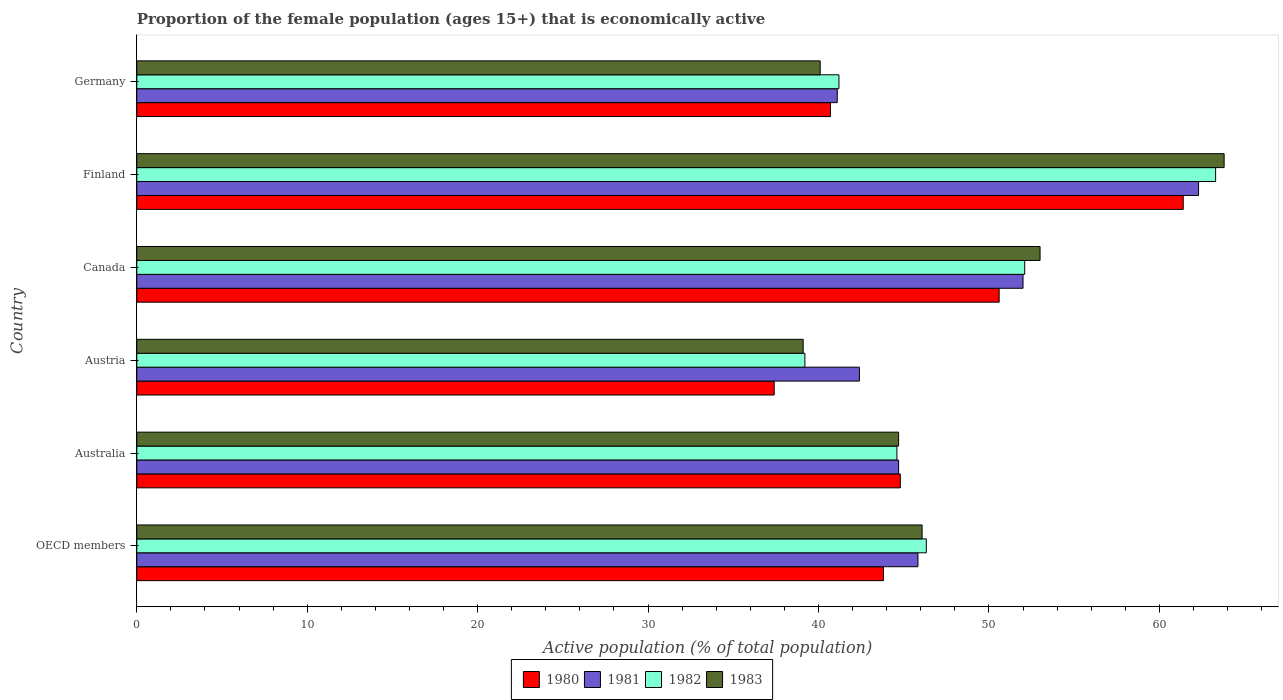How many different coloured bars are there?
Make the answer very short. 4. How many groups of bars are there?
Offer a terse response. 6. Are the number of bars per tick equal to the number of legend labels?
Your answer should be compact. Yes. How many bars are there on the 3rd tick from the top?
Your answer should be compact. 4. How many bars are there on the 1st tick from the bottom?
Your answer should be compact. 4. What is the label of the 4th group of bars from the top?
Make the answer very short. Austria. What is the proportion of the female population that is economically active in 1983 in Germany?
Make the answer very short. 40.1. Across all countries, what is the maximum proportion of the female population that is economically active in 1980?
Provide a succinct answer. 61.4. Across all countries, what is the minimum proportion of the female population that is economically active in 1980?
Make the answer very short. 37.4. In which country was the proportion of the female population that is economically active in 1981 minimum?
Your answer should be very brief. Germany. What is the total proportion of the female population that is economically active in 1983 in the graph?
Offer a terse response. 286.78. What is the difference between the proportion of the female population that is economically active in 1981 in Austria and that in Germany?
Offer a very short reply. 1.3. What is the difference between the proportion of the female population that is economically active in 1981 in OECD members and the proportion of the female population that is economically active in 1982 in Finland?
Provide a short and direct response. -17.46. What is the average proportion of the female population that is economically active in 1983 per country?
Your answer should be very brief. 47.8. What is the difference between the proportion of the female population that is economically active in 1981 and proportion of the female population that is economically active in 1980 in Finland?
Provide a short and direct response. 0.9. What is the ratio of the proportion of the female population that is economically active in 1982 in Austria to that in Finland?
Your response must be concise. 0.62. Is the difference between the proportion of the female population that is economically active in 1981 in Austria and Finland greater than the difference between the proportion of the female population that is economically active in 1980 in Austria and Finland?
Your answer should be very brief. Yes. What is the difference between the highest and the second highest proportion of the female population that is economically active in 1982?
Ensure brevity in your answer.  11.2. What is the difference between the highest and the lowest proportion of the female population that is economically active in 1982?
Provide a short and direct response. 24.1. In how many countries, is the proportion of the female population that is economically active in 1980 greater than the average proportion of the female population that is economically active in 1980 taken over all countries?
Keep it short and to the point. 2. Is it the case that in every country, the sum of the proportion of the female population that is economically active in 1983 and proportion of the female population that is economically active in 1980 is greater than the sum of proportion of the female population that is economically active in 1981 and proportion of the female population that is economically active in 1982?
Offer a very short reply. No. Is it the case that in every country, the sum of the proportion of the female population that is economically active in 1980 and proportion of the female population that is economically active in 1983 is greater than the proportion of the female population that is economically active in 1982?
Your answer should be compact. Yes. Are all the bars in the graph horizontal?
Provide a succinct answer. Yes. Are the values on the major ticks of X-axis written in scientific E-notation?
Your answer should be very brief. No. Does the graph contain any zero values?
Keep it short and to the point. No. How are the legend labels stacked?
Offer a very short reply. Horizontal. What is the title of the graph?
Your answer should be very brief. Proportion of the female population (ages 15+) that is economically active. What is the label or title of the X-axis?
Keep it short and to the point. Active population (% of total population). What is the Active population (% of total population) in 1980 in OECD members?
Offer a terse response. 43.81. What is the Active population (% of total population) of 1981 in OECD members?
Your response must be concise. 45.84. What is the Active population (% of total population) of 1982 in OECD members?
Offer a terse response. 46.32. What is the Active population (% of total population) of 1983 in OECD members?
Your response must be concise. 46.08. What is the Active population (% of total population) of 1980 in Australia?
Give a very brief answer. 44.8. What is the Active population (% of total population) of 1981 in Australia?
Offer a terse response. 44.7. What is the Active population (% of total population) of 1982 in Australia?
Offer a very short reply. 44.6. What is the Active population (% of total population) of 1983 in Australia?
Your answer should be very brief. 44.7. What is the Active population (% of total population) of 1980 in Austria?
Keep it short and to the point. 37.4. What is the Active population (% of total population) of 1981 in Austria?
Offer a very short reply. 42.4. What is the Active population (% of total population) of 1982 in Austria?
Offer a very short reply. 39.2. What is the Active population (% of total population) in 1983 in Austria?
Give a very brief answer. 39.1. What is the Active population (% of total population) in 1980 in Canada?
Provide a short and direct response. 50.6. What is the Active population (% of total population) in 1981 in Canada?
Offer a very short reply. 52. What is the Active population (% of total population) in 1982 in Canada?
Keep it short and to the point. 52.1. What is the Active population (% of total population) in 1983 in Canada?
Keep it short and to the point. 53. What is the Active population (% of total population) in 1980 in Finland?
Offer a very short reply. 61.4. What is the Active population (% of total population) in 1981 in Finland?
Provide a short and direct response. 62.3. What is the Active population (% of total population) of 1982 in Finland?
Offer a very short reply. 63.3. What is the Active population (% of total population) of 1983 in Finland?
Your answer should be compact. 63.8. What is the Active population (% of total population) in 1980 in Germany?
Offer a terse response. 40.7. What is the Active population (% of total population) of 1981 in Germany?
Provide a short and direct response. 41.1. What is the Active population (% of total population) in 1982 in Germany?
Offer a terse response. 41.2. What is the Active population (% of total population) of 1983 in Germany?
Your answer should be very brief. 40.1. Across all countries, what is the maximum Active population (% of total population) in 1980?
Make the answer very short. 61.4. Across all countries, what is the maximum Active population (% of total population) in 1981?
Provide a succinct answer. 62.3. Across all countries, what is the maximum Active population (% of total population) of 1982?
Your answer should be compact. 63.3. Across all countries, what is the maximum Active population (% of total population) of 1983?
Your answer should be very brief. 63.8. Across all countries, what is the minimum Active population (% of total population) of 1980?
Give a very brief answer. 37.4. Across all countries, what is the minimum Active population (% of total population) of 1981?
Your answer should be compact. 41.1. Across all countries, what is the minimum Active population (% of total population) of 1982?
Your answer should be very brief. 39.2. Across all countries, what is the minimum Active population (% of total population) of 1983?
Your answer should be compact. 39.1. What is the total Active population (% of total population) in 1980 in the graph?
Offer a terse response. 278.71. What is the total Active population (% of total population) of 1981 in the graph?
Ensure brevity in your answer.  288.34. What is the total Active population (% of total population) of 1982 in the graph?
Offer a very short reply. 286.72. What is the total Active population (% of total population) in 1983 in the graph?
Your response must be concise. 286.78. What is the difference between the Active population (% of total population) of 1980 in OECD members and that in Australia?
Offer a terse response. -0.99. What is the difference between the Active population (% of total population) in 1981 in OECD members and that in Australia?
Make the answer very short. 1.14. What is the difference between the Active population (% of total population) in 1982 in OECD members and that in Australia?
Give a very brief answer. 1.72. What is the difference between the Active population (% of total population) of 1983 in OECD members and that in Australia?
Offer a terse response. 1.38. What is the difference between the Active population (% of total population) in 1980 in OECD members and that in Austria?
Make the answer very short. 6.41. What is the difference between the Active population (% of total population) in 1981 in OECD members and that in Austria?
Give a very brief answer. 3.44. What is the difference between the Active population (% of total population) in 1982 in OECD members and that in Austria?
Make the answer very short. 7.12. What is the difference between the Active population (% of total population) in 1983 in OECD members and that in Austria?
Offer a very short reply. 6.98. What is the difference between the Active population (% of total population) of 1980 in OECD members and that in Canada?
Your response must be concise. -6.79. What is the difference between the Active population (% of total population) of 1981 in OECD members and that in Canada?
Make the answer very short. -6.16. What is the difference between the Active population (% of total population) in 1982 in OECD members and that in Canada?
Offer a terse response. -5.78. What is the difference between the Active population (% of total population) in 1983 in OECD members and that in Canada?
Provide a succinct answer. -6.92. What is the difference between the Active population (% of total population) in 1980 in OECD members and that in Finland?
Give a very brief answer. -17.59. What is the difference between the Active population (% of total population) of 1981 in OECD members and that in Finland?
Give a very brief answer. -16.46. What is the difference between the Active population (% of total population) in 1982 in OECD members and that in Finland?
Keep it short and to the point. -16.98. What is the difference between the Active population (% of total population) in 1983 in OECD members and that in Finland?
Provide a succinct answer. -17.72. What is the difference between the Active population (% of total population) in 1980 in OECD members and that in Germany?
Make the answer very short. 3.11. What is the difference between the Active population (% of total population) in 1981 in OECD members and that in Germany?
Give a very brief answer. 4.74. What is the difference between the Active population (% of total population) in 1982 in OECD members and that in Germany?
Make the answer very short. 5.12. What is the difference between the Active population (% of total population) in 1983 in OECD members and that in Germany?
Give a very brief answer. 5.98. What is the difference between the Active population (% of total population) of 1983 in Australia and that in Austria?
Give a very brief answer. 5.6. What is the difference between the Active population (% of total population) of 1980 in Australia and that in Canada?
Keep it short and to the point. -5.8. What is the difference between the Active population (% of total population) in 1981 in Australia and that in Canada?
Make the answer very short. -7.3. What is the difference between the Active population (% of total population) in 1982 in Australia and that in Canada?
Provide a succinct answer. -7.5. What is the difference between the Active population (% of total population) in 1980 in Australia and that in Finland?
Provide a succinct answer. -16.6. What is the difference between the Active population (% of total population) of 1981 in Australia and that in Finland?
Provide a short and direct response. -17.6. What is the difference between the Active population (% of total population) of 1982 in Australia and that in Finland?
Your answer should be very brief. -18.7. What is the difference between the Active population (% of total population) of 1983 in Australia and that in Finland?
Your answer should be compact. -19.1. What is the difference between the Active population (% of total population) of 1980 in Australia and that in Germany?
Your answer should be compact. 4.1. What is the difference between the Active population (% of total population) in 1981 in Australia and that in Germany?
Your response must be concise. 3.6. What is the difference between the Active population (% of total population) of 1980 in Austria and that in Canada?
Offer a very short reply. -13.2. What is the difference between the Active population (% of total population) in 1981 in Austria and that in Canada?
Your answer should be compact. -9.6. What is the difference between the Active population (% of total population) of 1983 in Austria and that in Canada?
Your response must be concise. -13.9. What is the difference between the Active population (% of total population) of 1981 in Austria and that in Finland?
Keep it short and to the point. -19.9. What is the difference between the Active population (% of total population) of 1982 in Austria and that in Finland?
Provide a succinct answer. -24.1. What is the difference between the Active population (% of total population) in 1983 in Austria and that in Finland?
Offer a very short reply. -24.7. What is the difference between the Active population (% of total population) in 1980 in Austria and that in Germany?
Make the answer very short. -3.3. What is the difference between the Active population (% of total population) in 1981 in Austria and that in Germany?
Provide a succinct answer. 1.3. What is the difference between the Active population (% of total population) of 1982 in Austria and that in Germany?
Your answer should be compact. -2. What is the difference between the Active population (% of total population) in 1982 in Canada and that in Finland?
Provide a short and direct response. -11.2. What is the difference between the Active population (% of total population) in 1981 in Canada and that in Germany?
Your answer should be compact. 10.9. What is the difference between the Active population (% of total population) in 1980 in Finland and that in Germany?
Provide a succinct answer. 20.7. What is the difference between the Active population (% of total population) in 1981 in Finland and that in Germany?
Your answer should be very brief. 21.2. What is the difference between the Active population (% of total population) of 1982 in Finland and that in Germany?
Provide a short and direct response. 22.1. What is the difference between the Active population (% of total population) of 1983 in Finland and that in Germany?
Offer a very short reply. 23.7. What is the difference between the Active population (% of total population) in 1980 in OECD members and the Active population (% of total population) in 1981 in Australia?
Your response must be concise. -0.89. What is the difference between the Active population (% of total population) of 1980 in OECD members and the Active population (% of total population) of 1982 in Australia?
Keep it short and to the point. -0.79. What is the difference between the Active population (% of total population) in 1980 in OECD members and the Active population (% of total population) in 1983 in Australia?
Keep it short and to the point. -0.89. What is the difference between the Active population (% of total population) of 1981 in OECD members and the Active population (% of total population) of 1982 in Australia?
Keep it short and to the point. 1.24. What is the difference between the Active population (% of total population) of 1981 in OECD members and the Active population (% of total population) of 1983 in Australia?
Give a very brief answer. 1.14. What is the difference between the Active population (% of total population) of 1982 in OECD members and the Active population (% of total population) of 1983 in Australia?
Provide a short and direct response. 1.62. What is the difference between the Active population (% of total population) in 1980 in OECD members and the Active population (% of total population) in 1981 in Austria?
Provide a succinct answer. 1.41. What is the difference between the Active population (% of total population) of 1980 in OECD members and the Active population (% of total population) of 1982 in Austria?
Your answer should be compact. 4.61. What is the difference between the Active population (% of total population) in 1980 in OECD members and the Active population (% of total population) in 1983 in Austria?
Your response must be concise. 4.71. What is the difference between the Active population (% of total population) in 1981 in OECD members and the Active population (% of total population) in 1982 in Austria?
Keep it short and to the point. 6.64. What is the difference between the Active population (% of total population) in 1981 in OECD members and the Active population (% of total population) in 1983 in Austria?
Offer a very short reply. 6.74. What is the difference between the Active population (% of total population) in 1982 in OECD members and the Active population (% of total population) in 1983 in Austria?
Your answer should be very brief. 7.22. What is the difference between the Active population (% of total population) of 1980 in OECD members and the Active population (% of total population) of 1981 in Canada?
Provide a short and direct response. -8.19. What is the difference between the Active population (% of total population) of 1980 in OECD members and the Active population (% of total population) of 1982 in Canada?
Ensure brevity in your answer.  -8.29. What is the difference between the Active population (% of total population) of 1980 in OECD members and the Active population (% of total population) of 1983 in Canada?
Your answer should be very brief. -9.19. What is the difference between the Active population (% of total population) of 1981 in OECD members and the Active population (% of total population) of 1982 in Canada?
Provide a short and direct response. -6.26. What is the difference between the Active population (% of total population) in 1981 in OECD members and the Active population (% of total population) in 1983 in Canada?
Keep it short and to the point. -7.16. What is the difference between the Active population (% of total population) in 1982 in OECD members and the Active population (% of total population) in 1983 in Canada?
Provide a succinct answer. -6.68. What is the difference between the Active population (% of total population) of 1980 in OECD members and the Active population (% of total population) of 1981 in Finland?
Your answer should be compact. -18.49. What is the difference between the Active population (% of total population) in 1980 in OECD members and the Active population (% of total population) in 1982 in Finland?
Offer a very short reply. -19.49. What is the difference between the Active population (% of total population) of 1980 in OECD members and the Active population (% of total population) of 1983 in Finland?
Provide a short and direct response. -19.99. What is the difference between the Active population (% of total population) in 1981 in OECD members and the Active population (% of total population) in 1982 in Finland?
Offer a very short reply. -17.46. What is the difference between the Active population (% of total population) in 1981 in OECD members and the Active population (% of total population) in 1983 in Finland?
Your answer should be very brief. -17.96. What is the difference between the Active population (% of total population) of 1982 in OECD members and the Active population (% of total population) of 1983 in Finland?
Offer a very short reply. -17.48. What is the difference between the Active population (% of total population) of 1980 in OECD members and the Active population (% of total population) of 1981 in Germany?
Give a very brief answer. 2.71. What is the difference between the Active population (% of total population) in 1980 in OECD members and the Active population (% of total population) in 1982 in Germany?
Your answer should be compact. 2.61. What is the difference between the Active population (% of total population) of 1980 in OECD members and the Active population (% of total population) of 1983 in Germany?
Your answer should be very brief. 3.71. What is the difference between the Active population (% of total population) of 1981 in OECD members and the Active population (% of total population) of 1982 in Germany?
Your answer should be compact. 4.64. What is the difference between the Active population (% of total population) in 1981 in OECD members and the Active population (% of total population) in 1983 in Germany?
Your response must be concise. 5.74. What is the difference between the Active population (% of total population) in 1982 in OECD members and the Active population (% of total population) in 1983 in Germany?
Give a very brief answer. 6.22. What is the difference between the Active population (% of total population) of 1980 in Australia and the Active population (% of total population) of 1981 in Austria?
Keep it short and to the point. 2.4. What is the difference between the Active population (% of total population) in 1980 in Australia and the Active population (% of total population) in 1983 in Austria?
Offer a very short reply. 5.7. What is the difference between the Active population (% of total population) in 1980 in Australia and the Active population (% of total population) in 1981 in Canada?
Give a very brief answer. -7.2. What is the difference between the Active population (% of total population) in 1980 in Australia and the Active population (% of total population) in 1982 in Canada?
Provide a short and direct response. -7.3. What is the difference between the Active population (% of total population) of 1980 in Australia and the Active population (% of total population) of 1983 in Canada?
Offer a terse response. -8.2. What is the difference between the Active population (% of total population) in 1981 in Australia and the Active population (% of total population) in 1982 in Canada?
Your response must be concise. -7.4. What is the difference between the Active population (% of total population) of 1982 in Australia and the Active population (% of total population) of 1983 in Canada?
Provide a short and direct response. -8.4. What is the difference between the Active population (% of total population) of 1980 in Australia and the Active population (% of total population) of 1981 in Finland?
Your response must be concise. -17.5. What is the difference between the Active population (% of total population) of 1980 in Australia and the Active population (% of total population) of 1982 in Finland?
Offer a very short reply. -18.5. What is the difference between the Active population (% of total population) of 1981 in Australia and the Active population (% of total population) of 1982 in Finland?
Your answer should be very brief. -18.6. What is the difference between the Active population (% of total population) in 1981 in Australia and the Active population (% of total population) in 1983 in Finland?
Offer a terse response. -19.1. What is the difference between the Active population (% of total population) of 1982 in Australia and the Active population (% of total population) of 1983 in Finland?
Your answer should be very brief. -19.2. What is the difference between the Active population (% of total population) of 1980 in Australia and the Active population (% of total population) of 1981 in Germany?
Ensure brevity in your answer.  3.7. What is the difference between the Active population (% of total population) of 1981 in Australia and the Active population (% of total population) of 1982 in Germany?
Make the answer very short. 3.5. What is the difference between the Active population (% of total population) in 1981 in Australia and the Active population (% of total population) in 1983 in Germany?
Provide a succinct answer. 4.6. What is the difference between the Active population (% of total population) of 1982 in Australia and the Active population (% of total population) of 1983 in Germany?
Make the answer very short. 4.5. What is the difference between the Active population (% of total population) of 1980 in Austria and the Active population (% of total population) of 1981 in Canada?
Your answer should be compact. -14.6. What is the difference between the Active population (% of total population) of 1980 in Austria and the Active population (% of total population) of 1982 in Canada?
Your answer should be very brief. -14.7. What is the difference between the Active population (% of total population) in 1980 in Austria and the Active population (% of total population) in 1983 in Canada?
Provide a short and direct response. -15.6. What is the difference between the Active population (% of total population) of 1980 in Austria and the Active population (% of total population) of 1981 in Finland?
Provide a succinct answer. -24.9. What is the difference between the Active population (% of total population) of 1980 in Austria and the Active population (% of total population) of 1982 in Finland?
Offer a terse response. -25.9. What is the difference between the Active population (% of total population) of 1980 in Austria and the Active population (% of total population) of 1983 in Finland?
Offer a terse response. -26.4. What is the difference between the Active population (% of total population) in 1981 in Austria and the Active population (% of total population) in 1982 in Finland?
Keep it short and to the point. -20.9. What is the difference between the Active population (% of total population) in 1981 in Austria and the Active population (% of total population) in 1983 in Finland?
Ensure brevity in your answer.  -21.4. What is the difference between the Active population (% of total population) in 1982 in Austria and the Active population (% of total population) in 1983 in Finland?
Provide a short and direct response. -24.6. What is the difference between the Active population (% of total population) of 1980 in Austria and the Active population (% of total population) of 1981 in Germany?
Offer a terse response. -3.7. What is the difference between the Active population (% of total population) of 1981 in Austria and the Active population (% of total population) of 1983 in Germany?
Provide a short and direct response. 2.3. What is the difference between the Active population (% of total population) in 1982 in Austria and the Active population (% of total population) in 1983 in Germany?
Provide a short and direct response. -0.9. What is the difference between the Active population (% of total population) in 1980 in Canada and the Active population (% of total population) in 1981 in Finland?
Your response must be concise. -11.7. What is the difference between the Active population (% of total population) in 1980 in Canada and the Active population (% of total population) in 1983 in Finland?
Ensure brevity in your answer.  -13.2. What is the difference between the Active population (% of total population) of 1980 in Canada and the Active population (% of total population) of 1982 in Germany?
Offer a terse response. 9.4. What is the difference between the Active population (% of total population) in 1980 in Canada and the Active population (% of total population) in 1983 in Germany?
Your response must be concise. 10.5. What is the difference between the Active population (% of total population) of 1981 in Canada and the Active population (% of total population) of 1982 in Germany?
Offer a very short reply. 10.8. What is the difference between the Active population (% of total population) in 1980 in Finland and the Active population (% of total population) in 1981 in Germany?
Your answer should be compact. 20.3. What is the difference between the Active population (% of total population) in 1980 in Finland and the Active population (% of total population) in 1982 in Germany?
Your answer should be compact. 20.2. What is the difference between the Active population (% of total population) in 1980 in Finland and the Active population (% of total population) in 1983 in Germany?
Your answer should be very brief. 21.3. What is the difference between the Active population (% of total population) of 1981 in Finland and the Active population (% of total population) of 1982 in Germany?
Offer a terse response. 21.1. What is the difference between the Active population (% of total population) in 1982 in Finland and the Active population (% of total population) in 1983 in Germany?
Give a very brief answer. 23.2. What is the average Active population (% of total population) of 1980 per country?
Your answer should be very brief. 46.45. What is the average Active population (% of total population) of 1981 per country?
Make the answer very short. 48.06. What is the average Active population (% of total population) in 1982 per country?
Give a very brief answer. 47.79. What is the average Active population (% of total population) of 1983 per country?
Make the answer very short. 47.8. What is the difference between the Active population (% of total population) in 1980 and Active population (% of total population) in 1981 in OECD members?
Your answer should be very brief. -2.03. What is the difference between the Active population (% of total population) in 1980 and Active population (% of total population) in 1982 in OECD members?
Your answer should be very brief. -2.52. What is the difference between the Active population (% of total population) in 1980 and Active population (% of total population) in 1983 in OECD members?
Provide a short and direct response. -2.27. What is the difference between the Active population (% of total population) in 1981 and Active population (% of total population) in 1982 in OECD members?
Offer a very short reply. -0.49. What is the difference between the Active population (% of total population) of 1981 and Active population (% of total population) of 1983 in OECD members?
Provide a short and direct response. -0.24. What is the difference between the Active population (% of total population) in 1982 and Active population (% of total population) in 1983 in OECD members?
Your answer should be compact. 0.25. What is the difference between the Active population (% of total population) in 1980 and Active population (% of total population) in 1981 in Australia?
Offer a very short reply. 0.1. What is the difference between the Active population (% of total population) of 1980 and Active population (% of total population) of 1983 in Australia?
Keep it short and to the point. 0.1. What is the difference between the Active population (% of total population) in 1981 and Active population (% of total population) in 1983 in Australia?
Your response must be concise. 0. What is the difference between the Active population (% of total population) of 1980 and Active population (% of total population) of 1981 in Austria?
Provide a short and direct response. -5. What is the difference between the Active population (% of total population) in 1980 and Active population (% of total population) in 1983 in Austria?
Offer a terse response. -1.7. What is the difference between the Active population (% of total population) of 1981 and Active population (% of total population) of 1983 in Austria?
Keep it short and to the point. 3.3. What is the difference between the Active population (% of total population) of 1982 and Active population (% of total population) of 1983 in Austria?
Your response must be concise. 0.1. What is the difference between the Active population (% of total population) in 1980 and Active population (% of total population) in 1981 in Canada?
Offer a very short reply. -1.4. What is the difference between the Active population (% of total population) of 1980 and Active population (% of total population) of 1981 in Finland?
Make the answer very short. -0.9. What is the difference between the Active population (% of total population) of 1980 and Active population (% of total population) of 1982 in Finland?
Keep it short and to the point. -1.9. What is the difference between the Active population (% of total population) of 1981 and Active population (% of total population) of 1983 in Finland?
Keep it short and to the point. -1.5. What is the difference between the Active population (% of total population) in 1980 and Active population (% of total population) in 1981 in Germany?
Your answer should be very brief. -0.4. What is the difference between the Active population (% of total population) in 1980 and Active population (% of total population) in 1983 in Germany?
Provide a short and direct response. 0.6. What is the difference between the Active population (% of total population) of 1981 and Active population (% of total population) of 1982 in Germany?
Offer a very short reply. -0.1. What is the difference between the Active population (% of total population) in 1981 and Active population (% of total population) in 1983 in Germany?
Give a very brief answer. 1. What is the difference between the Active population (% of total population) in 1982 and Active population (% of total population) in 1983 in Germany?
Your answer should be very brief. 1.1. What is the ratio of the Active population (% of total population) of 1980 in OECD members to that in Australia?
Your answer should be very brief. 0.98. What is the ratio of the Active population (% of total population) of 1981 in OECD members to that in Australia?
Make the answer very short. 1.03. What is the ratio of the Active population (% of total population) in 1982 in OECD members to that in Australia?
Provide a succinct answer. 1.04. What is the ratio of the Active population (% of total population) of 1983 in OECD members to that in Australia?
Keep it short and to the point. 1.03. What is the ratio of the Active population (% of total population) in 1980 in OECD members to that in Austria?
Keep it short and to the point. 1.17. What is the ratio of the Active population (% of total population) in 1981 in OECD members to that in Austria?
Your answer should be very brief. 1.08. What is the ratio of the Active population (% of total population) of 1982 in OECD members to that in Austria?
Give a very brief answer. 1.18. What is the ratio of the Active population (% of total population) of 1983 in OECD members to that in Austria?
Ensure brevity in your answer.  1.18. What is the ratio of the Active population (% of total population) in 1980 in OECD members to that in Canada?
Provide a succinct answer. 0.87. What is the ratio of the Active population (% of total population) of 1981 in OECD members to that in Canada?
Your answer should be compact. 0.88. What is the ratio of the Active population (% of total population) of 1982 in OECD members to that in Canada?
Provide a succinct answer. 0.89. What is the ratio of the Active population (% of total population) of 1983 in OECD members to that in Canada?
Ensure brevity in your answer.  0.87. What is the ratio of the Active population (% of total population) in 1980 in OECD members to that in Finland?
Your answer should be compact. 0.71. What is the ratio of the Active population (% of total population) in 1981 in OECD members to that in Finland?
Provide a short and direct response. 0.74. What is the ratio of the Active population (% of total population) in 1982 in OECD members to that in Finland?
Offer a very short reply. 0.73. What is the ratio of the Active population (% of total population) of 1983 in OECD members to that in Finland?
Give a very brief answer. 0.72. What is the ratio of the Active population (% of total population) in 1980 in OECD members to that in Germany?
Ensure brevity in your answer.  1.08. What is the ratio of the Active population (% of total population) in 1981 in OECD members to that in Germany?
Ensure brevity in your answer.  1.12. What is the ratio of the Active population (% of total population) of 1982 in OECD members to that in Germany?
Provide a succinct answer. 1.12. What is the ratio of the Active population (% of total population) in 1983 in OECD members to that in Germany?
Give a very brief answer. 1.15. What is the ratio of the Active population (% of total population) of 1980 in Australia to that in Austria?
Your answer should be compact. 1.2. What is the ratio of the Active population (% of total population) in 1981 in Australia to that in Austria?
Offer a terse response. 1.05. What is the ratio of the Active population (% of total population) of 1982 in Australia to that in Austria?
Your response must be concise. 1.14. What is the ratio of the Active population (% of total population) in 1983 in Australia to that in Austria?
Ensure brevity in your answer.  1.14. What is the ratio of the Active population (% of total population) of 1980 in Australia to that in Canada?
Offer a very short reply. 0.89. What is the ratio of the Active population (% of total population) in 1981 in Australia to that in Canada?
Provide a succinct answer. 0.86. What is the ratio of the Active population (% of total population) in 1982 in Australia to that in Canada?
Make the answer very short. 0.86. What is the ratio of the Active population (% of total population) in 1983 in Australia to that in Canada?
Provide a short and direct response. 0.84. What is the ratio of the Active population (% of total population) in 1980 in Australia to that in Finland?
Offer a terse response. 0.73. What is the ratio of the Active population (% of total population) of 1981 in Australia to that in Finland?
Offer a terse response. 0.72. What is the ratio of the Active population (% of total population) in 1982 in Australia to that in Finland?
Provide a succinct answer. 0.7. What is the ratio of the Active population (% of total population) of 1983 in Australia to that in Finland?
Ensure brevity in your answer.  0.7. What is the ratio of the Active population (% of total population) of 1980 in Australia to that in Germany?
Your response must be concise. 1.1. What is the ratio of the Active population (% of total population) in 1981 in Australia to that in Germany?
Make the answer very short. 1.09. What is the ratio of the Active population (% of total population) of 1982 in Australia to that in Germany?
Offer a terse response. 1.08. What is the ratio of the Active population (% of total population) in 1983 in Australia to that in Germany?
Offer a terse response. 1.11. What is the ratio of the Active population (% of total population) of 1980 in Austria to that in Canada?
Offer a terse response. 0.74. What is the ratio of the Active population (% of total population) in 1981 in Austria to that in Canada?
Make the answer very short. 0.82. What is the ratio of the Active population (% of total population) of 1982 in Austria to that in Canada?
Keep it short and to the point. 0.75. What is the ratio of the Active population (% of total population) in 1983 in Austria to that in Canada?
Provide a short and direct response. 0.74. What is the ratio of the Active population (% of total population) in 1980 in Austria to that in Finland?
Ensure brevity in your answer.  0.61. What is the ratio of the Active population (% of total population) in 1981 in Austria to that in Finland?
Give a very brief answer. 0.68. What is the ratio of the Active population (% of total population) of 1982 in Austria to that in Finland?
Provide a succinct answer. 0.62. What is the ratio of the Active population (% of total population) in 1983 in Austria to that in Finland?
Your response must be concise. 0.61. What is the ratio of the Active population (% of total population) in 1980 in Austria to that in Germany?
Your response must be concise. 0.92. What is the ratio of the Active population (% of total population) of 1981 in Austria to that in Germany?
Your answer should be compact. 1.03. What is the ratio of the Active population (% of total population) in 1982 in Austria to that in Germany?
Keep it short and to the point. 0.95. What is the ratio of the Active population (% of total population) of 1983 in Austria to that in Germany?
Provide a short and direct response. 0.98. What is the ratio of the Active population (% of total population) in 1980 in Canada to that in Finland?
Offer a very short reply. 0.82. What is the ratio of the Active population (% of total population) in 1981 in Canada to that in Finland?
Your answer should be very brief. 0.83. What is the ratio of the Active population (% of total population) of 1982 in Canada to that in Finland?
Make the answer very short. 0.82. What is the ratio of the Active population (% of total population) of 1983 in Canada to that in Finland?
Keep it short and to the point. 0.83. What is the ratio of the Active population (% of total population) in 1980 in Canada to that in Germany?
Make the answer very short. 1.24. What is the ratio of the Active population (% of total population) in 1981 in Canada to that in Germany?
Make the answer very short. 1.27. What is the ratio of the Active population (% of total population) of 1982 in Canada to that in Germany?
Offer a very short reply. 1.26. What is the ratio of the Active population (% of total population) in 1983 in Canada to that in Germany?
Your answer should be compact. 1.32. What is the ratio of the Active population (% of total population) of 1980 in Finland to that in Germany?
Your response must be concise. 1.51. What is the ratio of the Active population (% of total population) in 1981 in Finland to that in Germany?
Keep it short and to the point. 1.52. What is the ratio of the Active population (% of total population) in 1982 in Finland to that in Germany?
Offer a terse response. 1.54. What is the ratio of the Active population (% of total population) in 1983 in Finland to that in Germany?
Give a very brief answer. 1.59. What is the difference between the highest and the second highest Active population (% of total population) in 1980?
Offer a terse response. 10.8. What is the difference between the highest and the second highest Active population (% of total population) in 1981?
Your response must be concise. 10.3. What is the difference between the highest and the second highest Active population (% of total population) in 1982?
Offer a very short reply. 11.2. What is the difference between the highest and the second highest Active population (% of total population) of 1983?
Ensure brevity in your answer.  10.8. What is the difference between the highest and the lowest Active population (% of total population) of 1980?
Your answer should be very brief. 24. What is the difference between the highest and the lowest Active population (% of total population) in 1981?
Provide a short and direct response. 21.2. What is the difference between the highest and the lowest Active population (% of total population) of 1982?
Give a very brief answer. 24.1. What is the difference between the highest and the lowest Active population (% of total population) of 1983?
Provide a succinct answer. 24.7. 